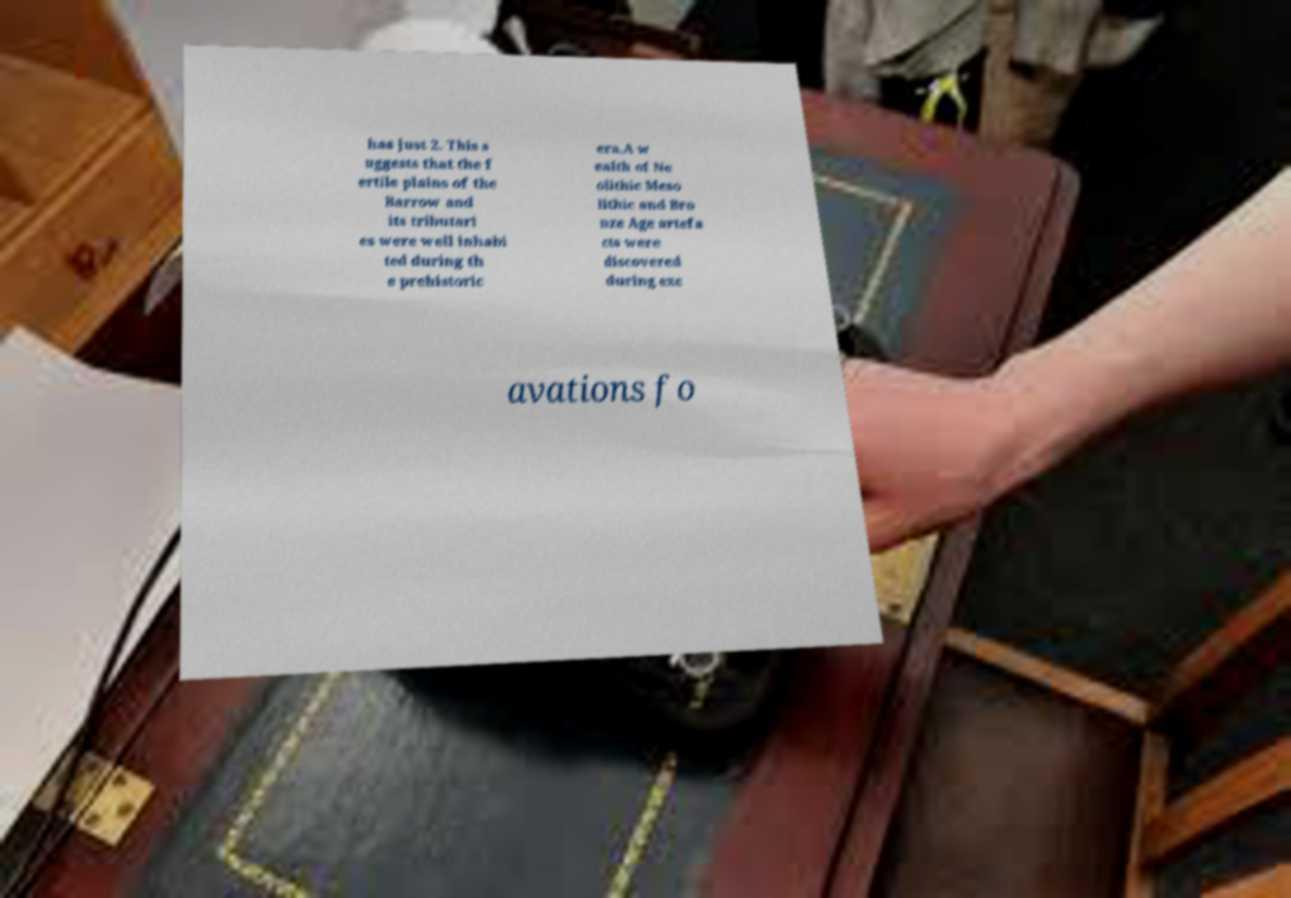Could you extract and type out the text from this image? has just 2. This s uggests that the f ertile plains of the Barrow and its tributari es were well inhabi ted during th e prehistoric era.A w ealth of Ne olithic Meso lithic and Bro nze Age artefa cts were discovered during exc avations fo 